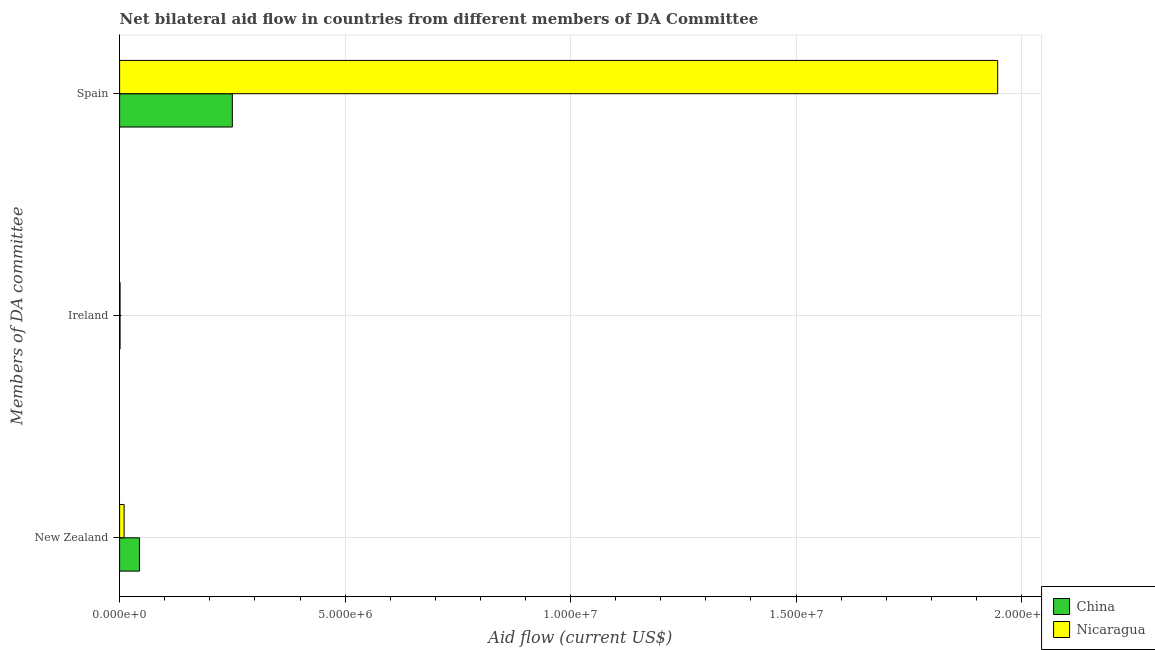How many groups of bars are there?
Provide a short and direct response. 3. How many bars are there on the 1st tick from the bottom?
Provide a short and direct response. 2. What is the label of the 3rd group of bars from the top?
Offer a very short reply. New Zealand. What is the amount of aid provided by ireland in Nicaragua?
Provide a succinct answer. 10000. Across all countries, what is the maximum amount of aid provided by spain?
Provide a short and direct response. 1.95e+07. Across all countries, what is the minimum amount of aid provided by ireland?
Your answer should be compact. 10000. In which country was the amount of aid provided by ireland maximum?
Your response must be concise. China. What is the total amount of aid provided by new zealand in the graph?
Keep it short and to the point. 5.40e+05. What is the difference between the amount of aid provided by new zealand in China and that in Nicaragua?
Ensure brevity in your answer.  3.40e+05. What is the difference between the amount of aid provided by spain in Nicaragua and the amount of aid provided by new zealand in China?
Keep it short and to the point. 1.90e+07. What is the difference between the amount of aid provided by new zealand and amount of aid provided by ireland in China?
Make the answer very short. 4.30e+05. What is the ratio of the amount of aid provided by spain in Nicaragua to that in China?
Give a very brief answer. 7.79. Is the amount of aid provided by new zealand in China less than that in Nicaragua?
Offer a very short reply. No. What is the difference between the highest and the second highest amount of aid provided by spain?
Offer a terse response. 1.70e+07. What is the difference between the highest and the lowest amount of aid provided by spain?
Your answer should be compact. 1.70e+07. What does the 1st bar from the top in New Zealand represents?
Provide a short and direct response. Nicaragua. Is it the case that in every country, the sum of the amount of aid provided by new zealand and amount of aid provided by ireland is greater than the amount of aid provided by spain?
Offer a very short reply. No. How many bars are there?
Offer a very short reply. 6. How many countries are there in the graph?
Your answer should be compact. 2. What is the difference between two consecutive major ticks on the X-axis?
Provide a succinct answer. 5.00e+06. Are the values on the major ticks of X-axis written in scientific E-notation?
Offer a very short reply. Yes. Does the graph contain any zero values?
Ensure brevity in your answer.  No. Where does the legend appear in the graph?
Keep it short and to the point. Bottom right. How many legend labels are there?
Offer a terse response. 2. What is the title of the graph?
Keep it short and to the point. Net bilateral aid flow in countries from different members of DA Committee. What is the label or title of the Y-axis?
Give a very brief answer. Members of DA committee. What is the Aid flow (current US$) in China in Ireland?
Ensure brevity in your answer.  10000. What is the Aid flow (current US$) in Nicaragua in Ireland?
Your response must be concise. 10000. What is the Aid flow (current US$) of China in Spain?
Offer a terse response. 2.50e+06. What is the Aid flow (current US$) of Nicaragua in Spain?
Provide a short and direct response. 1.95e+07. Across all Members of DA committee, what is the maximum Aid flow (current US$) in China?
Your answer should be very brief. 2.50e+06. Across all Members of DA committee, what is the maximum Aid flow (current US$) in Nicaragua?
Offer a terse response. 1.95e+07. What is the total Aid flow (current US$) in China in the graph?
Ensure brevity in your answer.  2.95e+06. What is the total Aid flow (current US$) in Nicaragua in the graph?
Your answer should be compact. 1.96e+07. What is the difference between the Aid flow (current US$) in China in New Zealand and that in Ireland?
Your answer should be very brief. 4.30e+05. What is the difference between the Aid flow (current US$) in China in New Zealand and that in Spain?
Offer a very short reply. -2.06e+06. What is the difference between the Aid flow (current US$) of Nicaragua in New Zealand and that in Spain?
Provide a short and direct response. -1.94e+07. What is the difference between the Aid flow (current US$) in China in Ireland and that in Spain?
Offer a very short reply. -2.49e+06. What is the difference between the Aid flow (current US$) of Nicaragua in Ireland and that in Spain?
Make the answer very short. -1.95e+07. What is the difference between the Aid flow (current US$) in China in New Zealand and the Aid flow (current US$) in Nicaragua in Ireland?
Your answer should be compact. 4.30e+05. What is the difference between the Aid flow (current US$) in China in New Zealand and the Aid flow (current US$) in Nicaragua in Spain?
Make the answer very short. -1.90e+07. What is the difference between the Aid flow (current US$) in China in Ireland and the Aid flow (current US$) in Nicaragua in Spain?
Keep it short and to the point. -1.95e+07. What is the average Aid flow (current US$) of China per Members of DA committee?
Offer a very short reply. 9.83e+05. What is the average Aid flow (current US$) of Nicaragua per Members of DA committee?
Provide a short and direct response. 6.53e+06. What is the difference between the Aid flow (current US$) in China and Aid flow (current US$) in Nicaragua in Spain?
Offer a very short reply. -1.70e+07. What is the ratio of the Aid flow (current US$) of China in New Zealand to that in Spain?
Offer a terse response. 0.18. What is the ratio of the Aid flow (current US$) of Nicaragua in New Zealand to that in Spain?
Keep it short and to the point. 0.01. What is the ratio of the Aid flow (current US$) of China in Ireland to that in Spain?
Offer a very short reply. 0. What is the ratio of the Aid flow (current US$) of Nicaragua in Ireland to that in Spain?
Your response must be concise. 0. What is the difference between the highest and the second highest Aid flow (current US$) in China?
Make the answer very short. 2.06e+06. What is the difference between the highest and the second highest Aid flow (current US$) of Nicaragua?
Provide a short and direct response. 1.94e+07. What is the difference between the highest and the lowest Aid flow (current US$) in China?
Your response must be concise. 2.49e+06. What is the difference between the highest and the lowest Aid flow (current US$) in Nicaragua?
Your answer should be compact. 1.95e+07. 